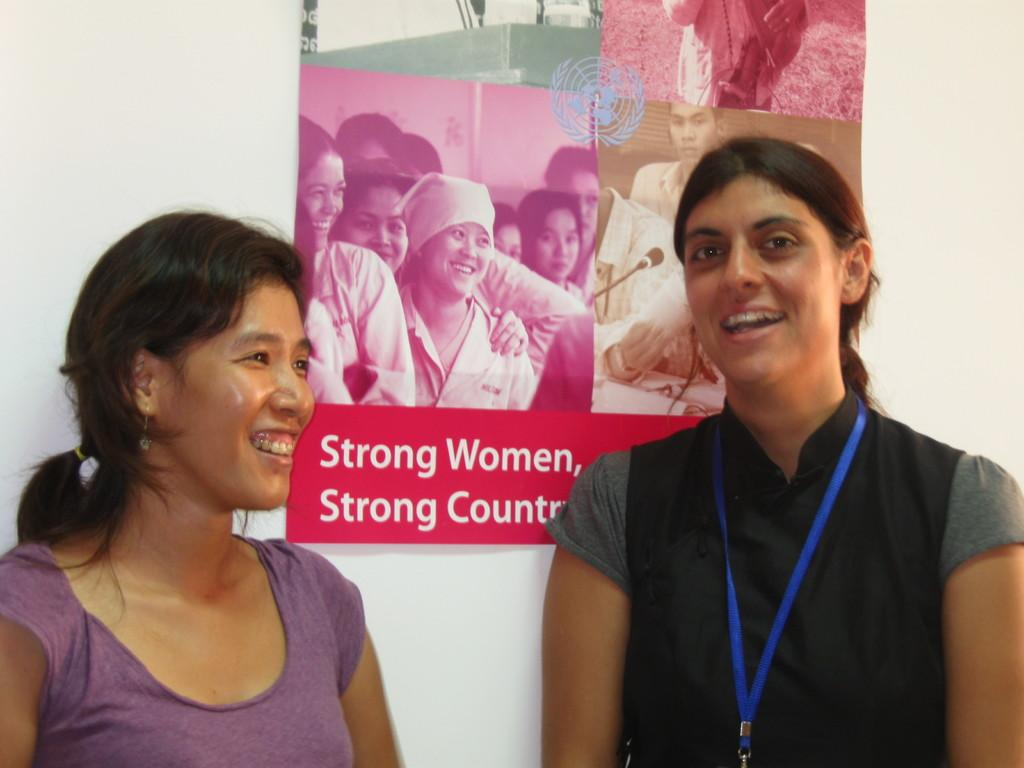Who or what can be seen in the image? There are people in the image. What is on the wall in the image? There is a poster on the wall. What can be found on the poster? The poster has text and images of persons on it. What type of ink is used to write the text on the poster? There is no information about the type of ink used on the poster, as the facts provided do not mention it. 